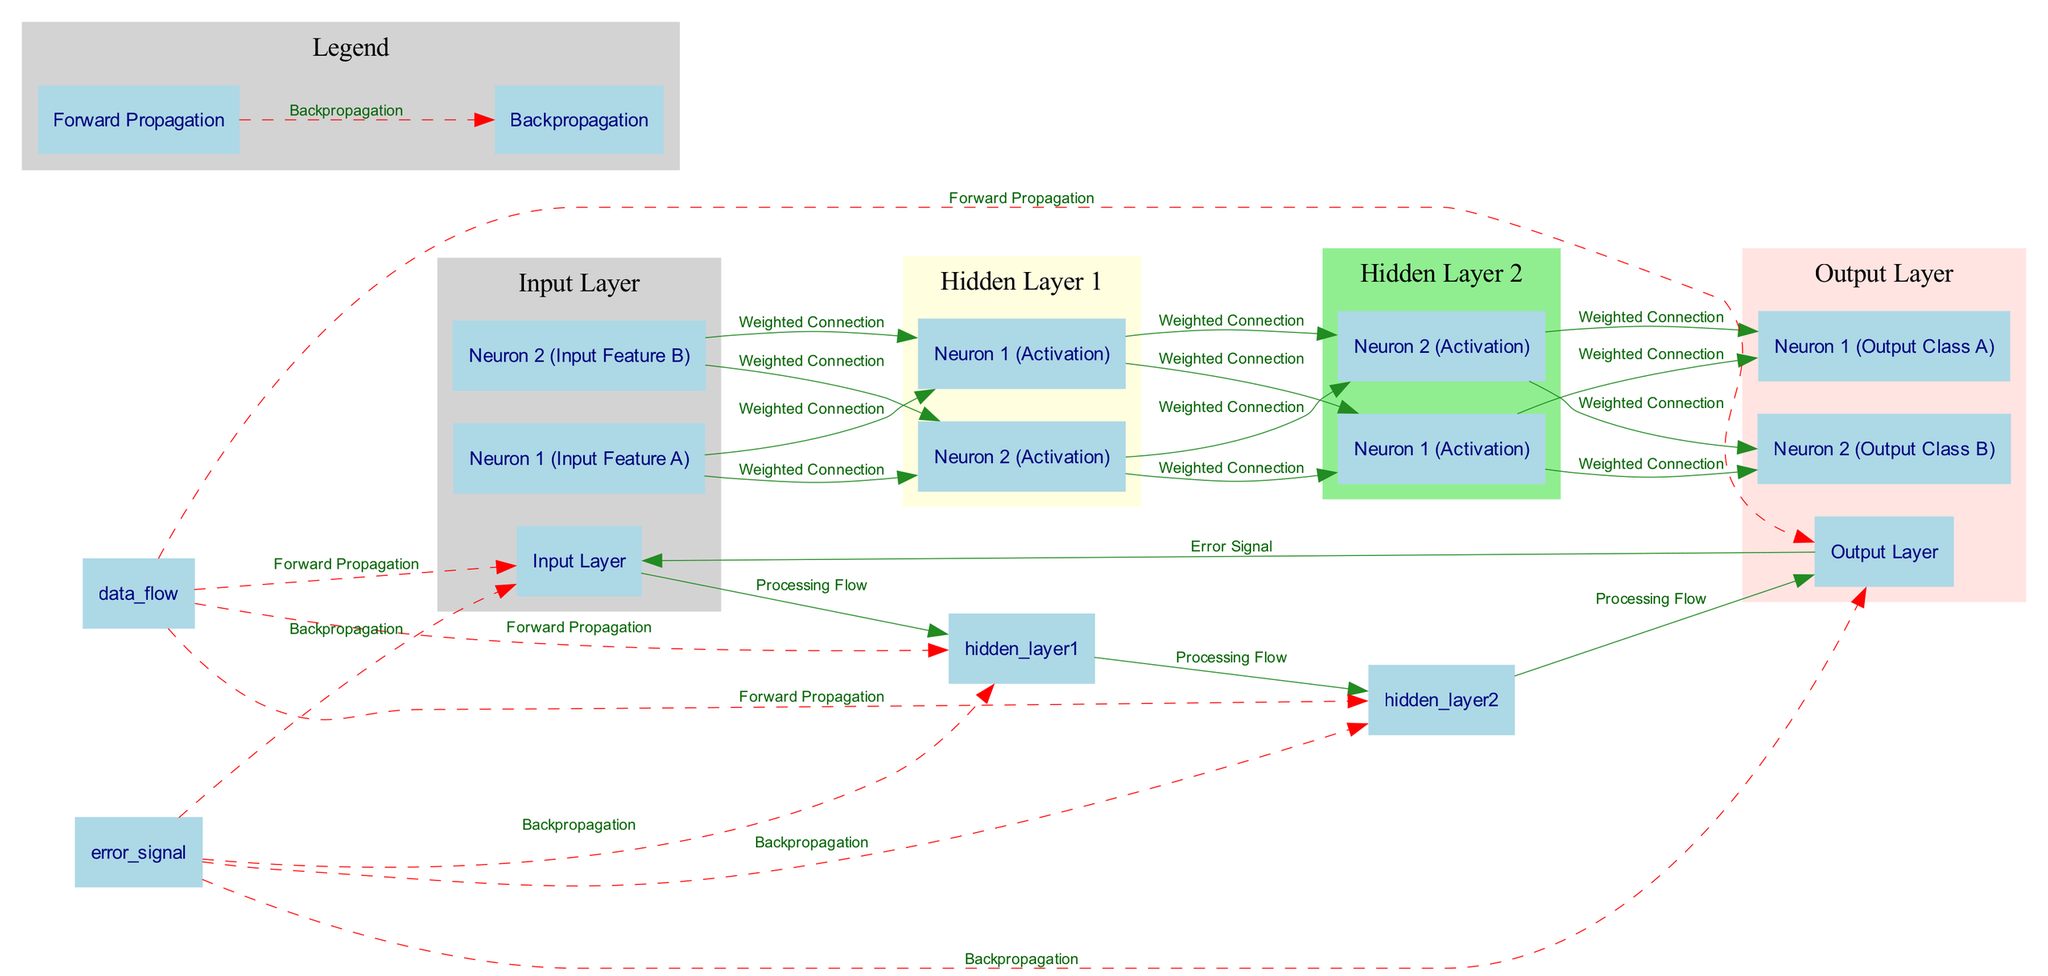What is the label of the input layer? The input layer has a specific node labeled as "Input Layer," which is directly mentioned in the diagram data under the nodes section.
Answer: Input Layer How many neurons are in the output layer? The output layer contains two specific nodes representing output classes, namely "Neuron 1 (Output Class A)" and "Neuron 2 (Output Class B)," leading to a total of two neurons.
Answer: 2 Which neurons in the first hidden layer are activated by "Neuron 1 (Input Feature A)"? "Neuron 1 (Input Feature A)" connects to two neurons in the first hidden layer: "Neuron 1 (Activation)" and "Neuron 2 (Activation)" through weighted connections.
Answer: Neuron 1 (Activation), Neuron 2 (Activation) What flows between the hidden layers? There are several "Weighted Connections" that link the neurons from one hidden layer to the next, specifically transitioning from "Hidden Layer 1" to "Hidden Layer 2."
Answer: Weighted Connections What is the direction of backpropagation in the diagram? The backpropagation direction is from the output layer through hidden layers back to the input layer, which is represented in the diagram as an "Error Signal."
Answer: Input Layer How many connections are there from the neurons in the second hidden layer to the output layer? Each neuron in the second hidden layer connects to both output neurons, leading to four connections in total: each neuron connects to "Neuron 1 (Output Class A)" and "Neuron 2 (Output Class B)".
Answer: 4 Which layer processes forward propagation? The forward propagation is indicated to flow through the input layer, hidden layers, and finally, to the output layer. It signifies the movement of data in the positive direction until output is reached.
Answer: Forward Propagation What type of neurons are present in the hidden layers? The hidden layers consist of activation neurons, specifically labeled as "Neuron 1 (Activation)" and "Neuron 2 (Activation)" for both hidden layers, signifying their functional role.
Answer: Neuron 1 (Activation), Neuron 2 (Activation) What connection type is used between the input neurons and hidden layer neurons? The connections from the input neurons to the hidden neurons are described as "Weighted Connections," indicating the importance of the data being processed through those links.
Answer: Weighted Connection 